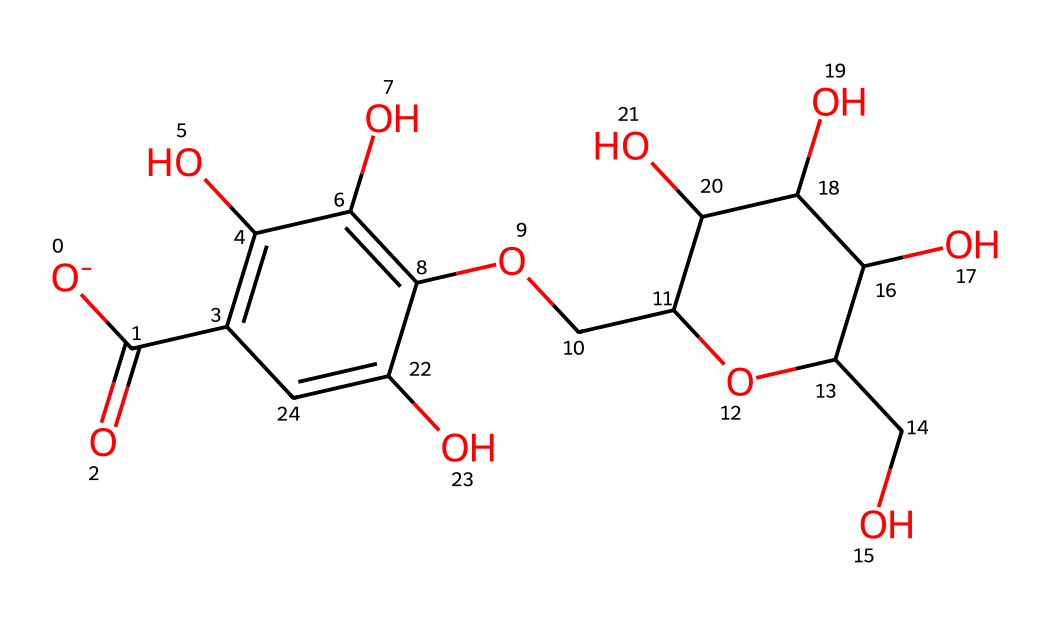What is the primary functional group present in this chemical? The primary functional group found in this chemical is a hydroxyl group (-OH) as indicated by multiple instances of -OH in the structure.
Answer: hydroxyl How many carbon atoms are in the molecular structure? By counting the carbon atoms in the structure from the SMILES representation, there are 12 carbon atoms present.
Answer: 12 What type of polymer does this molecule represent? This molecule represents a type of cellulose-derived fiber known as lyocell, characterized by its cellulose polymer structure.
Answer: lyocell How many ether linkages are present in the chemical structure? Examining the chemical structure, there is one ether linkage, which can be identified by the presence of the -O- connectivity between two carbon chains.
Answer: one What is the degree of polymerization (DP) indicated by the structure? The degree of polymerization can be inferred to be higher considering the repeating units of the cellulose-based structure; yet, an exact number usually requires additional information not visible here. However, it is commonly in the range of 100-200.
Answer: higher (approx. 100-200) What property makes lyocell fabrics moisture-wicking? The hydroxyl groups present in the molecular structure allow for strong hydrogen bonding with water molecules, which enhances its moisture-wicking properties.
Answer: hydrogen bonding 